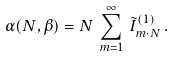Convert formula to latex. <formula><loc_0><loc_0><loc_500><loc_500>\alpha ( N , \beta ) = N \, \sum _ { m = 1 } ^ { \infty } \, { \tilde { I } } ^ { ( 1 ) } _ { m \cdot N } \, .</formula> 